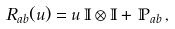<formula> <loc_0><loc_0><loc_500><loc_500>R _ { a b } ( u ) = u \, \mathbb { I } \otimes \mathbb { I } + \, \mathbb { P } _ { a b } \, ,</formula> 